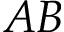<formula> <loc_0><loc_0><loc_500><loc_500>A B</formula> 